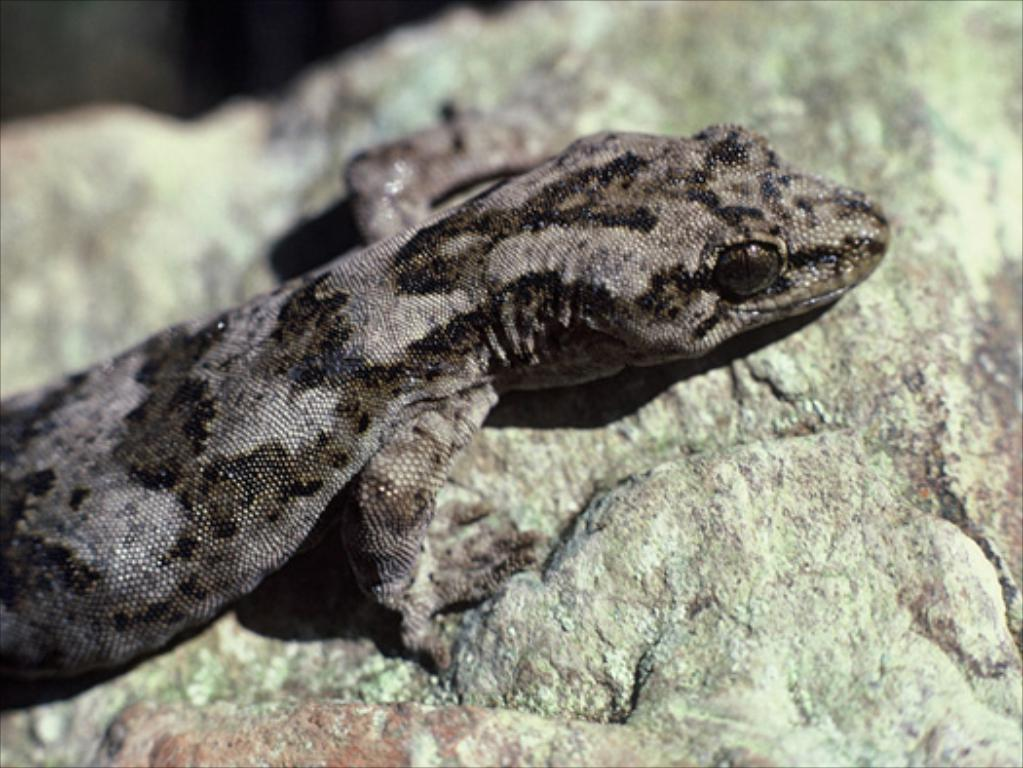What type of animal is present in the image? There is a lizard in the image. What surface is the lizard situated on? The lizard is on a stone. What type of company does the lizard work for in the image? The lizard is not a human and does not work for any company in the image. Is there a fight happening between the lizard and another animal in the image? There is no fight or any conflict involving the lizard in the image. 